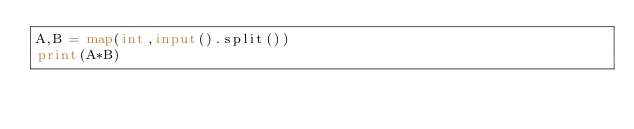Convert code to text. <code><loc_0><loc_0><loc_500><loc_500><_Python_>A,B = map(int,input().split())
print(A*B)</code> 